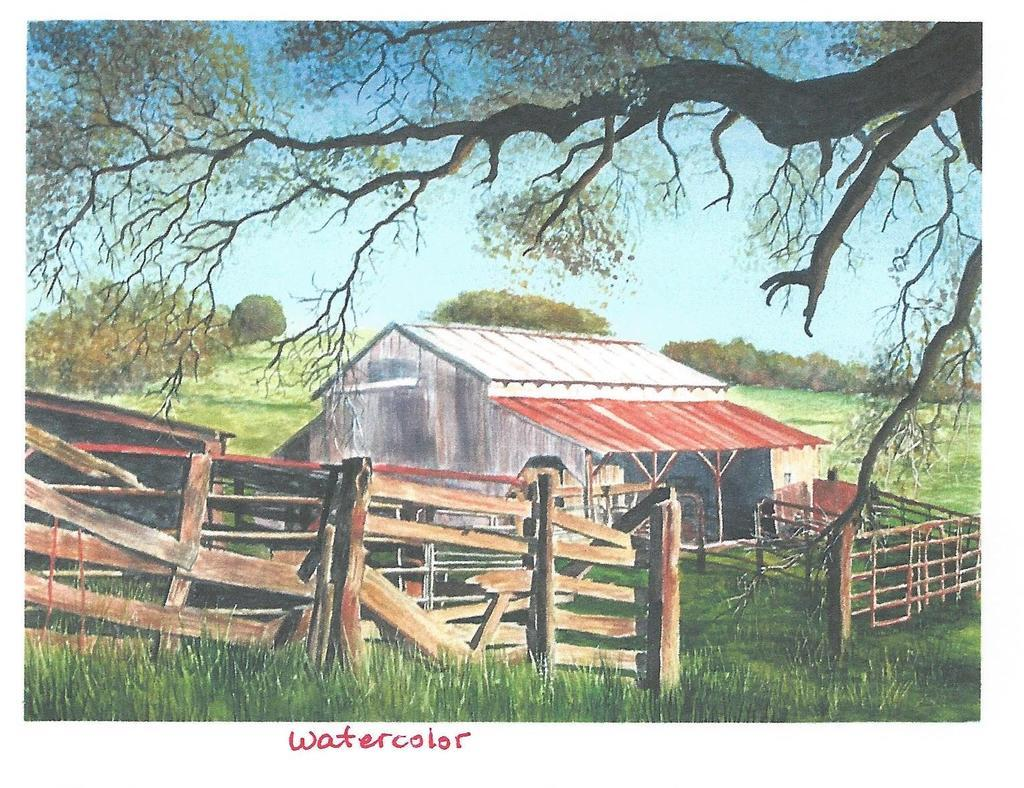<image>
Offer a succinct explanation of the picture presented. a postcard of a shed on a farm called watercolor 